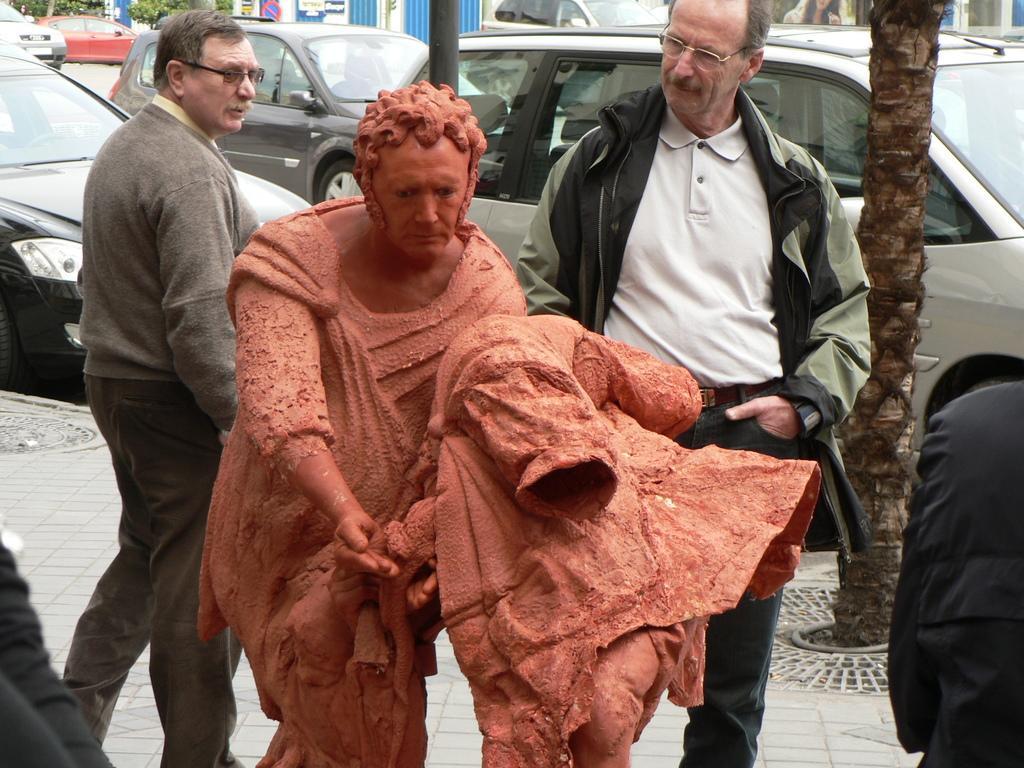In one or two sentences, can you explain what this image depicts? In this image I can see a statue in brown color. Back I can see few people walking. I can see few vehicles,trees,poles,signboards and buildings. 